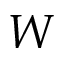Convert formula to latex. <formula><loc_0><loc_0><loc_500><loc_500>W</formula> 